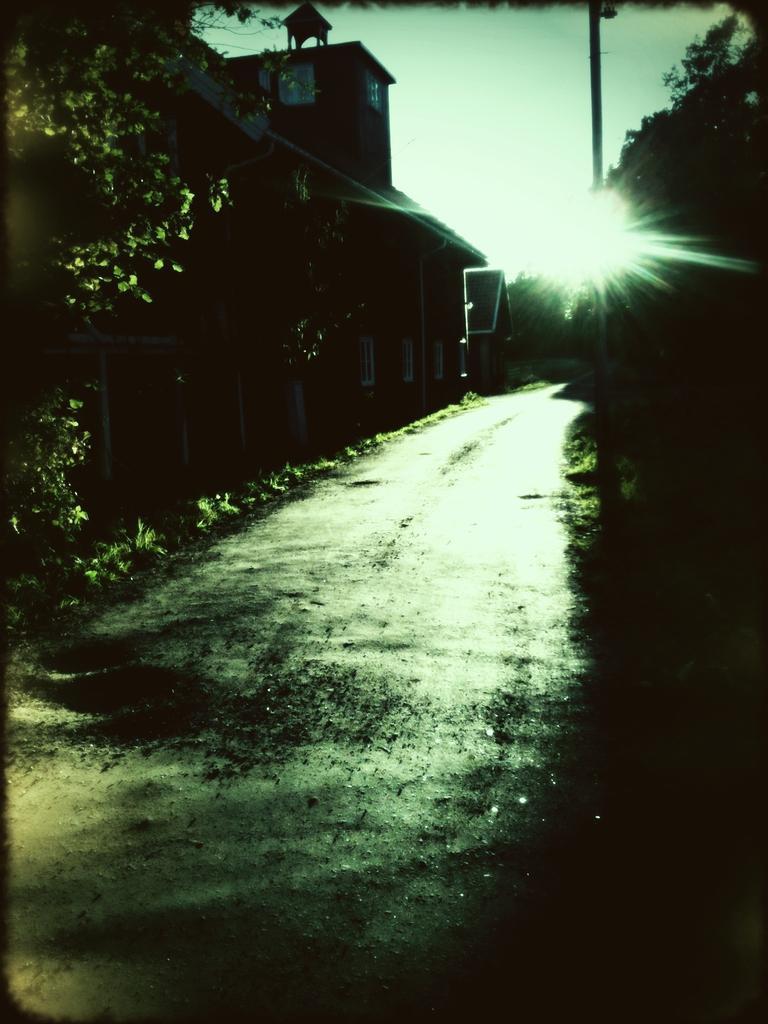Could you give a brief overview of what you see in this image? This is an edited image, we can see a walkway and houses. On the right side of the houses there is a pole and trees. Behind the houses there is the sky. 